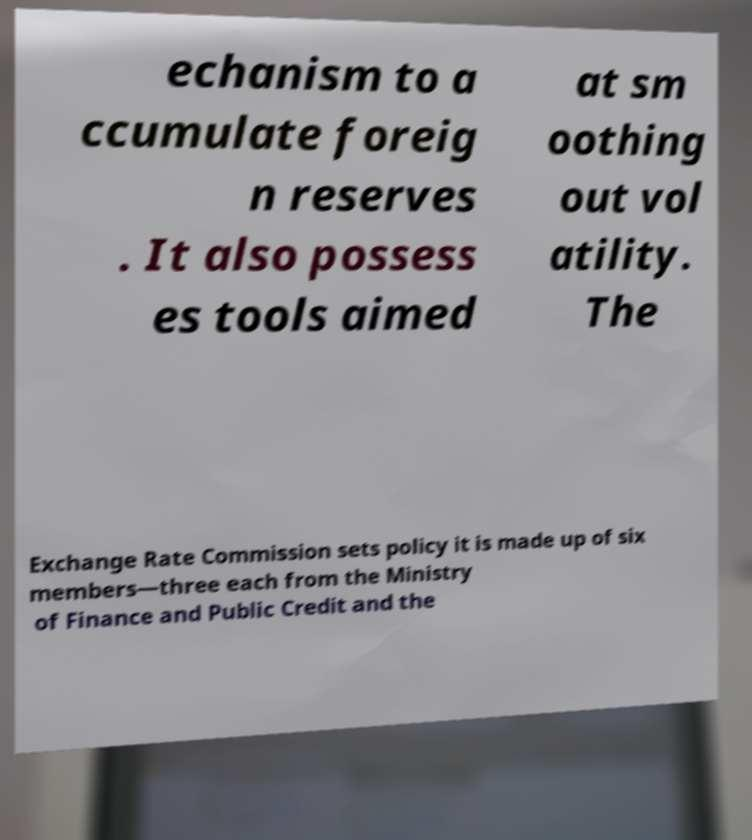Could you assist in decoding the text presented in this image and type it out clearly? echanism to a ccumulate foreig n reserves . It also possess es tools aimed at sm oothing out vol atility. The Exchange Rate Commission sets policy it is made up of six members—three each from the Ministry of Finance and Public Credit and the 